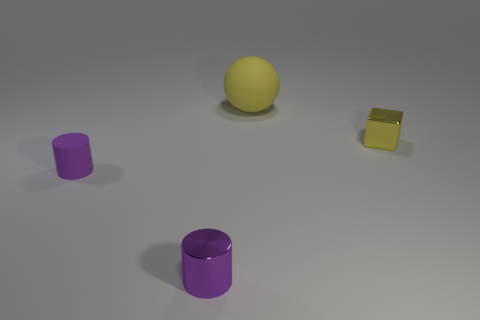Add 3 tiny purple cylinders. How many objects exist? 7 Subtract all cubes. How many objects are left? 3 Subtract all big purple cubes. Subtract all purple shiny things. How many objects are left? 3 Add 4 small shiny cylinders. How many small shiny cylinders are left? 5 Add 1 small brown shiny balls. How many small brown shiny balls exist? 1 Subtract 1 purple cylinders. How many objects are left? 3 